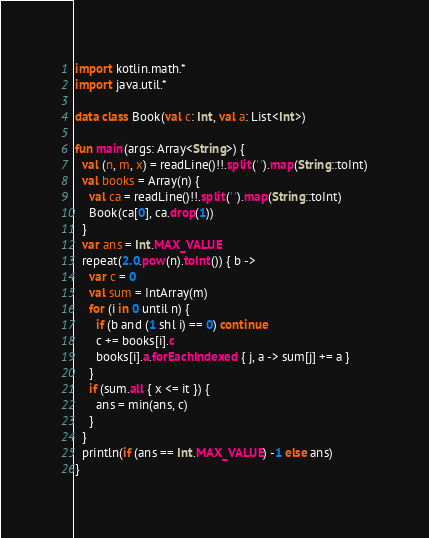Convert code to text. <code><loc_0><loc_0><loc_500><loc_500><_Kotlin_>import kotlin.math.*
import java.util.*

data class Book(val c: Int, val a: List<Int>)

fun main(args: Array<String>) {
  val (n, m, x) = readLine()!!.split(' ').map(String::toInt)
  val books = Array(n) {
    val ca = readLine()!!.split(' ').map(String::toInt)
    Book(ca[0], ca.drop(1))
  }
  var ans = Int.MAX_VALUE
  repeat(2.0.pow(n).toInt()) { b ->
    var c = 0
    val sum = IntArray(m)
    for (i in 0 until n) {
      if (b and (1 shl i) == 0) continue
      c += books[i].c
      books[i].a.forEachIndexed { j, a -> sum[j] += a }
    }
    if (sum.all { x <= it }) {
      ans = min(ans, c)
    }
  }
  println(if (ans == Int.MAX_VALUE) -1 else ans)
}
</code> 